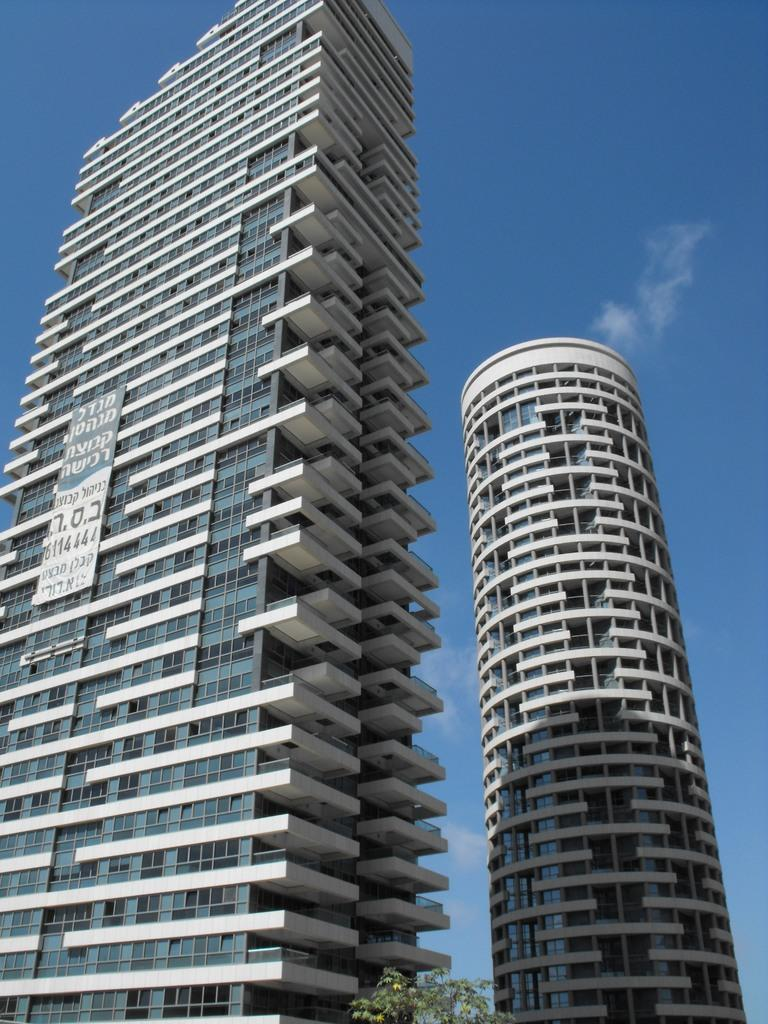How many buildings are present in the image? There are two buildings in the image. What type of windows do the buildings have? The buildings have glass windows. What can be seen in the background of the image? The sky is visible in the image. What decision did the sister make about the yam in the image? There is no sister or yam present in the image, so no such decision can be made. 